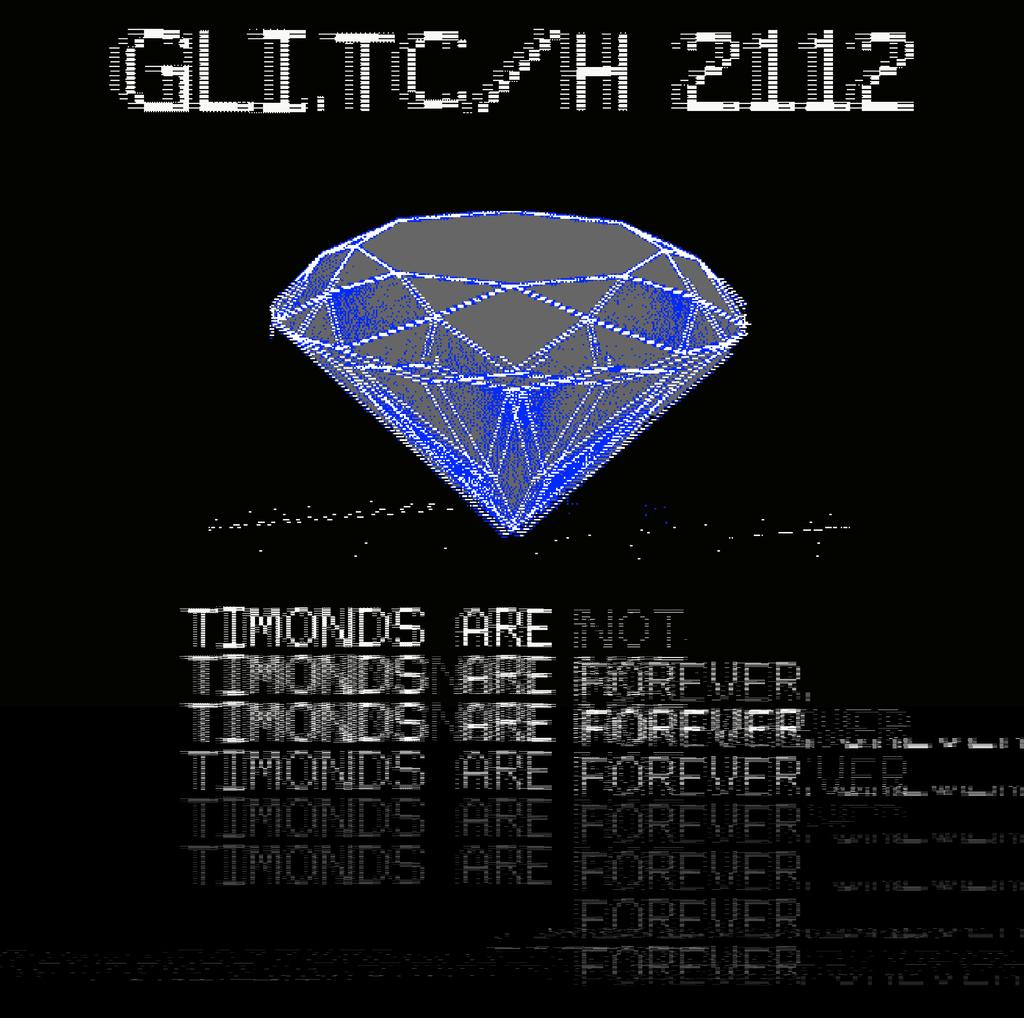What number glitch is seen?
Give a very brief answer. 2112. What color tent is on this diamond?
Provide a short and direct response. Answering does not require reading text in the image. 